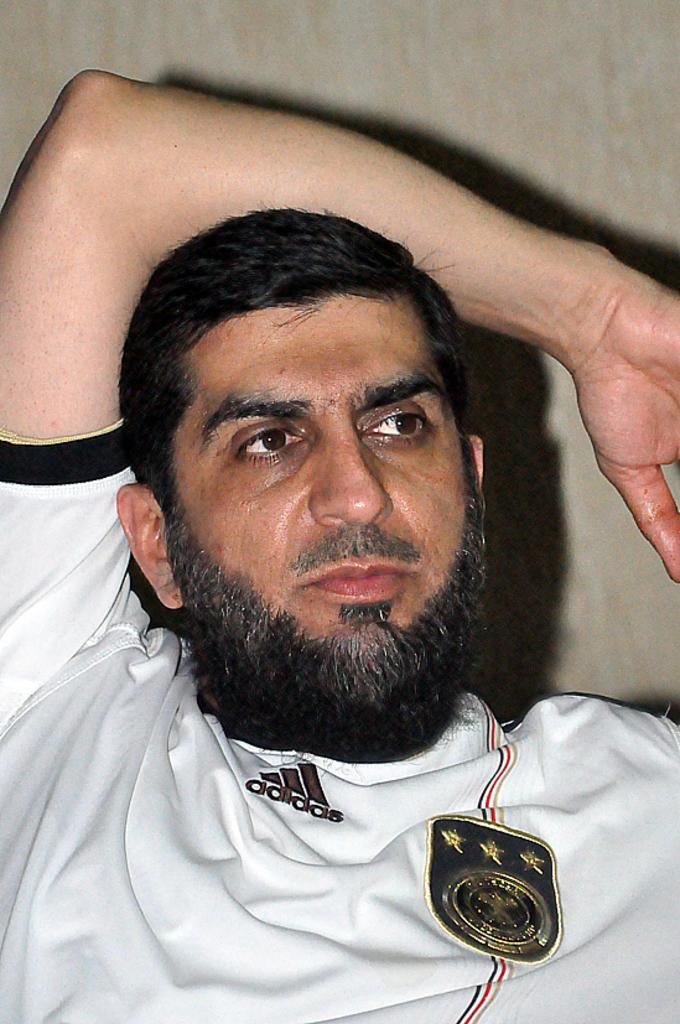Who is present in the image? There is a man in the image. What can be seen on the man's dress? The man's dress has an emblem on it. What is visible in the background of the image? There is a wall in the background of the image. What type of egg is the man holding in the image? There is no egg present in the image. Can you tell me where the map is located in the image? There is no map present in the image. 